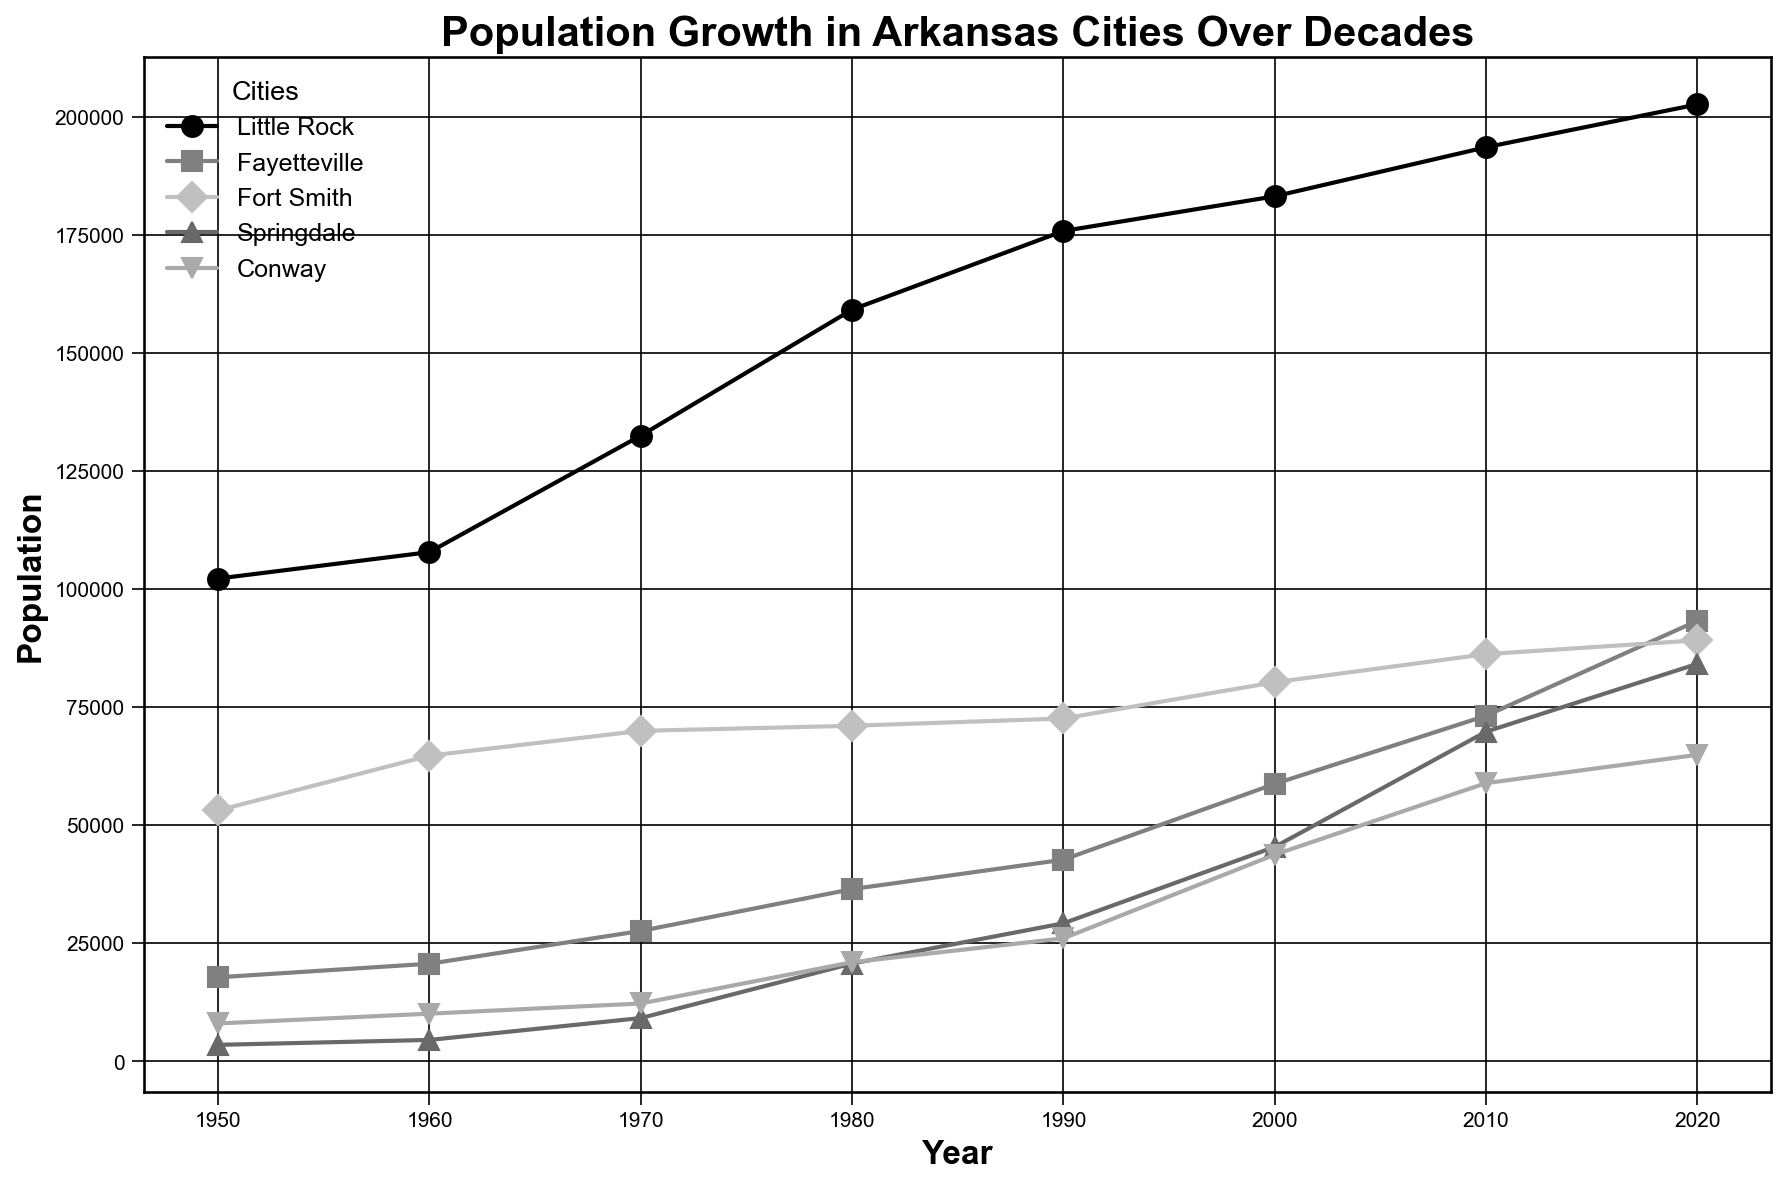What's the overall trend in population growth for Little Rock from 1950 to 2020? Little Rock's population growth can be assessed by looking at the data points from each decade between 1950 and 2020. The figure shows a general increasing trend: 102,213 (1950), 107,813 (1960), 132,483 (1970), 159,151 (1980), 175,795 (1990), 183,133 (2000), 193,524 (2010), and 202,591 (2020).
Answer: Increasing Which city had the highest population in 2020? To answer this question, examine the population data for all cities in the year 2020 on the figure. Little Rock has the highest population with 202,591.
Answer: Little Rock Compare the population growth of Fayetteville and Springdale from 1980 to 2020. Which city grew more? First, look at the populations in 1980 for Fayetteville (36,472) and Springdale (20,716). Then, look at the populations in 2020 for Fayetteville (93,268) and Springdale (84,161). Calculate the absolute growth: Fayetteville grew by 93,268 - 36,472 = 56,796, and Springdale grew by 84,161 - 20,716 = 63,445. Compare these values: 63,445 > 56,796.
Answer: Springdale What was the population of Fort Smith in 1970 and how does it compare to the population in 2010? Look at the population values for Fort Smith in 1970 (69,973) and 2010 (86,209). Compare the two numbers directly to see the increase.
Answer: 69,973 and 86,209; increased Which city showed the smallest population growth between 1950 and 2020? Calculate the population growth for each city by subtracting the 1950 population from the 2020 population. Find the minimum value among these:
- Little Rock: 202,591 - 102,213 = 100,378
- Fayetteville: 93,268 - 17,801 = 75,467
- Fort Smith: 89,142 - 53,132 = 36,010
- Springdale: 84,161 - 3,500 = 80,661
- Conway: 64,901 - 8,031 = 56,870
The smallest growth is Fort Smith with 36,010.
Answer: Fort Smith Among the five cities, which one had periods of stagnation or minimal growth for two consecutive decades? By examining the plot for trends across decades, Fort Smith shows nearly stagnant population change from 1980 to 1990 (71,048 to 72,591) and from 1990 to 2000 (72,591 to 80,268), indicating minimal growth.
Answer: Fort Smith 